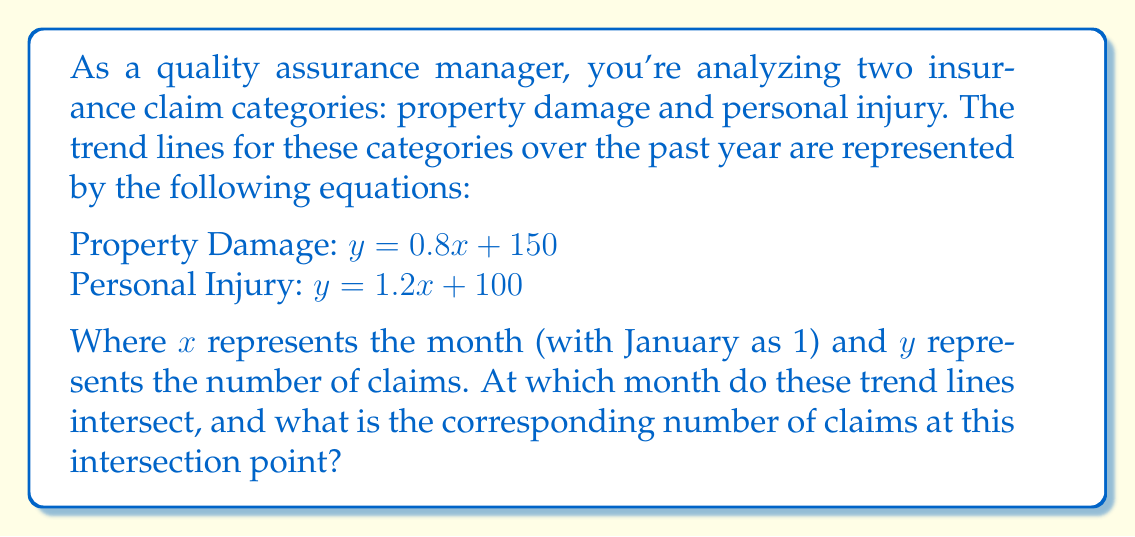Help me with this question. To find the intersection point of these two trend lines, we need to solve the system of equations:

$$\begin{cases}
y = 0.8x + 150 \\
y = 1.2x + 100
\end{cases}$$

Step 1: Set the equations equal to each other since they intersect at a point where y-values are the same.
$0.8x + 150 = 1.2x + 100$

Step 2: Subtract $0.8x$ from both sides.
$150 = 0.4x + 100$

Step 3: Subtract 100 from both sides.
$50 = 0.4x$

Step 4: Divide both sides by 0.4 to solve for x.
$x = 50 \div 0.4 = 125$

Step 5: Now that we know $x = 125$, we can substitute this value into either of the original equations to find $y$. Let's use the property damage equation:

$y = 0.8(125) + 150$
$y = 100 + 150 = 250$

Therefore, the trend lines intersect at the point (125, 250).

Step 6: Interpret the result:
The x-value of 125 represents the 125th month, which is equivalent to 10 years and 5 months from the starting point (January of the first year).
Answer: (125, 250); 10 years and 5 months after January of the first year, with 250 claims. 